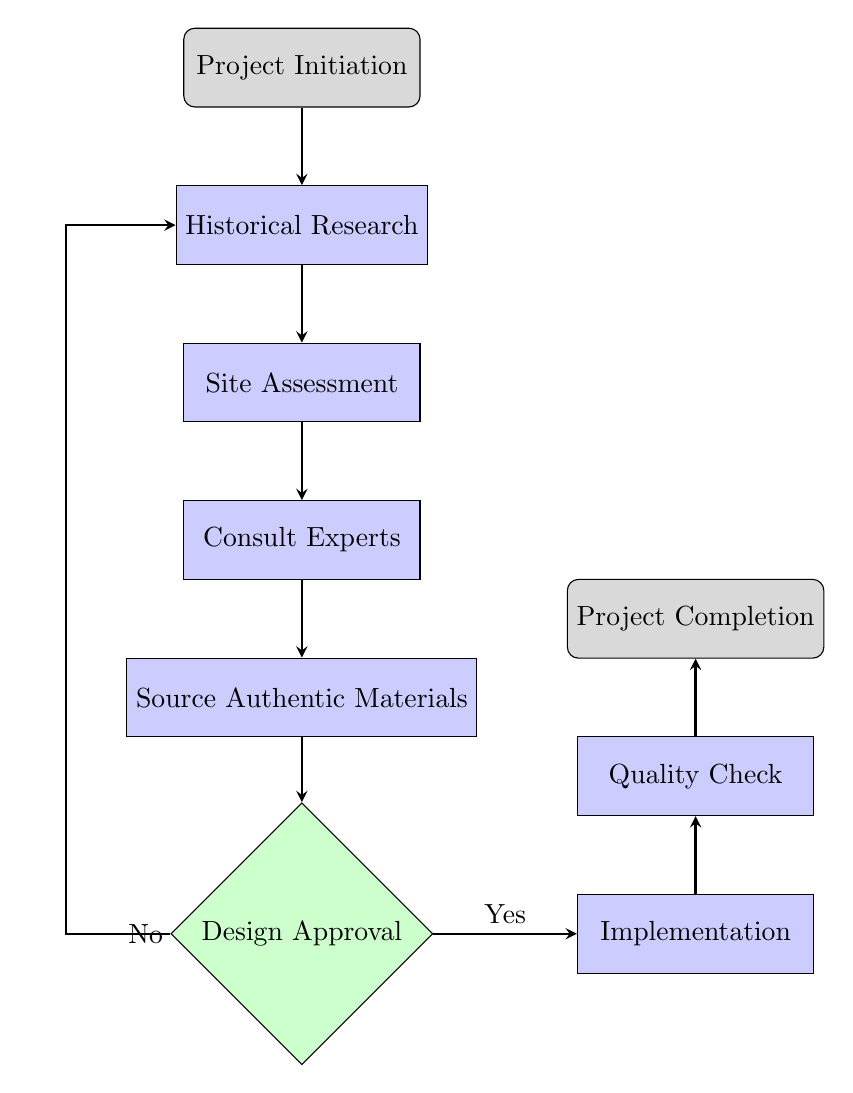What is the first step in the selection process? The first node in the flowchart is labeled "Project Initiation," indicating that this is the initial step in the selection process.
Answer: Project Initiation How many process nodes are in the diagram? Counting all nodes labeled as "process," we find Historical Research, Site Assessment, Consult Experts, Source Authentic Materials, Implementation, and Quality Check, totaling six process nodes.
Answer: 6 What comes after "Source Authentic Materials"? The flow proceeds from "Source Authentic Materials" directly down to "Design Approval," as shown by the arrow connecting these two nodes.
Answer: Design Approval What decision follows after the "Design Approval"? After reaching the "Design Approval" node, a decision must be made about whether to proceed. If approved (Yes), it leads to "Implementation." If not (No), it loops back to "Historical Research."
Answer: Implementation What kind of specialists should be consulted according to the diagram? The node labeled "Consult Experts" specifies that consultations should include Gothic architecture historians and conservators, indicating the required expertise for this step.
Answer: Gothic architecture historians and conservators If the design is not approved, where does the flow go next? If the decision at "Design Approval" is No, the flow diagram indicates that it loops back to "Historical Research," suggesting a review of the initial findings and documents.
Answer: Historical Research What is the last step in the selection process for authentic Gothic architectural elements? According to the flowchart, the final process is labeled "Project Completion," marking the end of the selection and restoration process.
Answer: Project Completion How many nodes are designated for decision-making in the diagram? The diagram contains one decision node labeled "Design Approval," indicating that there is only one point where a decision needs to be made in the process.
Answer: 1 What must be verified during the "Quality Check"? The process node labeled "Quality Check" emphasizes the requirement to verify both the integrity and authenticity of the work completed during the restoration project.
Answer: Integrity and authenticity 